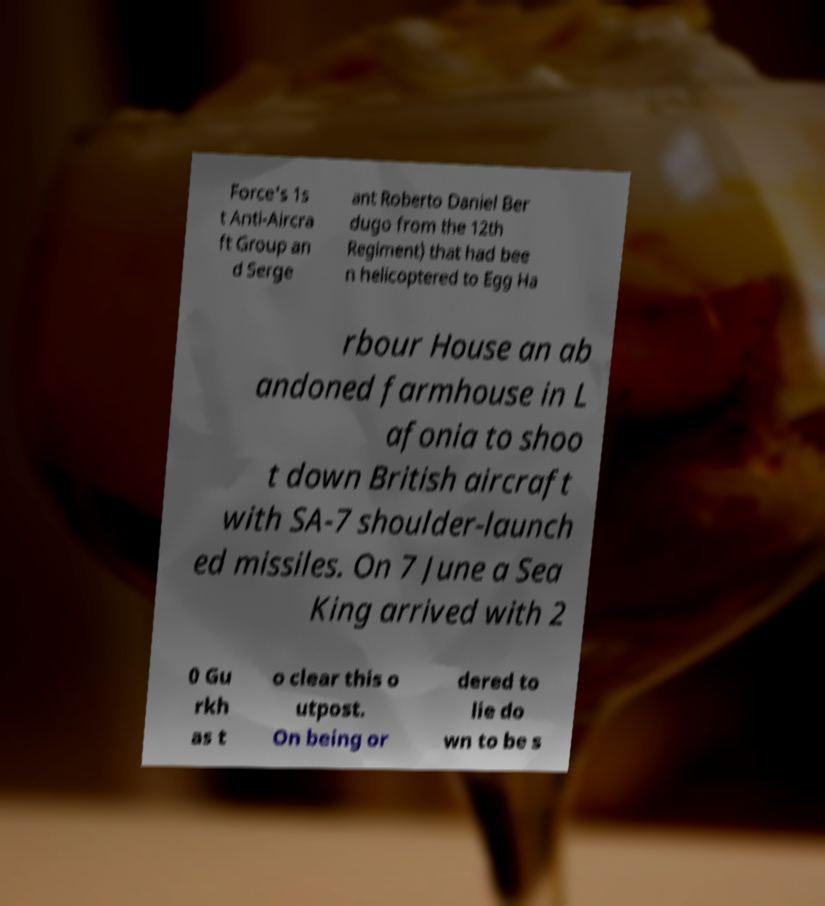For documentation purposes, I need the text within this image transcribed. Could you provide that? Force's 1s t Anti-Aircra ft Group an d Serge ant Roberto Daniel Ber dugo from the 12th Regiment) that had bee n helicoptered to Egg Ha rbour House an ab andoned farmhouse in L afonia to shoo t down British aircraft with SA-7 shoulder-launch ed missiles. On 7 June a Sea King arrived with 2 0 Gu rkh as t o clear this o utpost. On being or dered to lie do wn to be s 